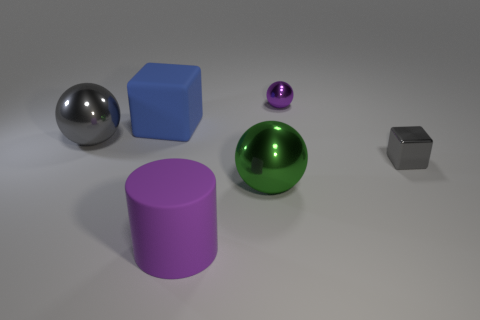How many other objects are the same color as the small metal sphere?
Provide a short and direct response. 1. There is a matte thing left of the big cylinder; is it the same shape as the tiny purple object?
Ensure brevity in your answer.  No. What material is the other object that is the same shape as the tiny gray thing?
Your answer should be very brief. Rubber. How many purple metallic spheres are the same size as the purple rubber object?
Provide a succinct answer. 0. There is a shiny sphere that is both to the right of the large gray metal sphere and in front of the purple metallic object; what color is it?
Give a very brief answer. Green. Is the number of small purple balls less than the number of tiny brown cylinders?
Keep it short and to the point. No. Do the tiny ball and the large rubber object that is right of the rubber block have the same color?
Give a very brief answer. Yes. Are there an equal number of purple metallic things that are to the left of the large rubber block and tiny gray blocks that are in front of the tiny metallic ball?
Ensure brevity in your answer.  No. What number of green objects have the same shape as the big purple rubber thing?
Offer a very short reply. 0. Are any big blue objects visible?
Your answer should be very brief. Yes. 